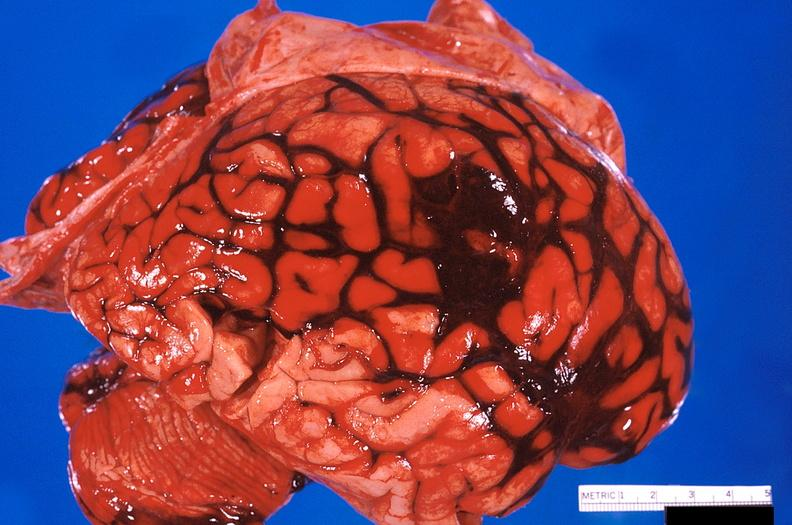what is present?
Answer the question using a single word or phrase. Nervous 